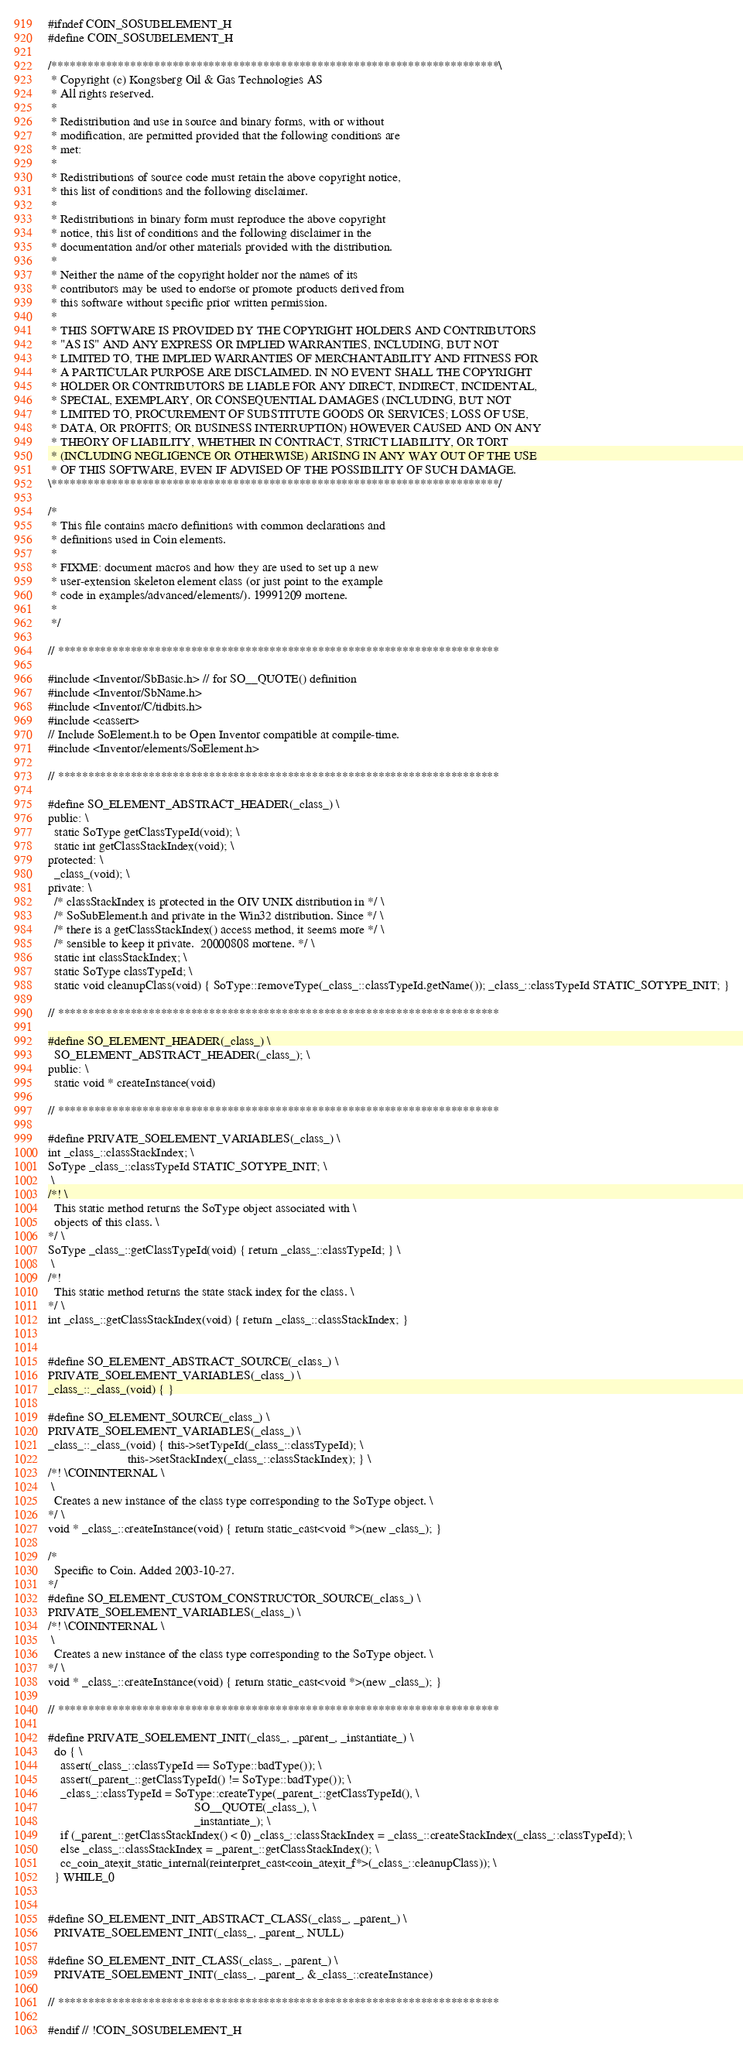Convert code to text. <code><loc_0><loc_0><loc_500><loc_500><_C_>#ifndef COIN_SOSUBELEMENT_H
#define COIN_SOSUBELEMENT_H

/**************************************************************************\
 * Copyright (c) Kongsberg Oil & Gas Technologies AS
 * All rights reserved.
 * 
 * Redistribution and use in source and binary forms, with or without
 * modification, are permitted provided that the following conditions are
 * met:
 * 
 * Redistributions of source code must retain the above copyright notice,
 * this list of conditions and the following disclaimer.
 * 
 * Redistributions in binary form must reproduce the above copyright
 * notice, this list of conditions and the following disclaimer in the
 * documentation and/or other materials provided with the distribution.
 * 
 * Neither the name of the copyright holder nor the names of its
 * contributors may be used to endorse or promote products derived from
 * this software without specific prior written permission.
 * 
 * THIS SOFTWARE IS PROVIDED BY THE COPYRIGHT HOLDERS AND CONTRIBUTORS
 * "AS IS" AND ANY EXPRESS OR IMPLIED WARRANTIES, INCLUDING, BUT NOT
 * LIMITED TO, THE IMPLIED WARRANTIES OF MERCHANTABILITY AND FITNESS FOR
 * A PARTICULAR PURPOSE ARE DISCLAIMED. IN NO EVENT SHALL THE COPYRIGHT
 * HOLDER OR CONTRIBUTORS BE LIABLE FOR ANY DIRECT, INDIRECT, INCIDENTAL,
 * SPECIAL, EXEMPLARY, OR CONSEQUENTIAL DAMAGES (INCLUDING, BUT NOT
 * LIMITED TO, PROCUREMENT OF SUBSTITUTE GOODS OR SERVICES; LOSS OF USE,
 * DATA, OR PROFITS; OR BUSINESS INTERRUPTION) HOWEVER CAUSED AND ON ANY
 * THEORY OF LIABILITY, WHETHER IN CONTRACT, STRICT LIABILITY, OR TORT
 * (INCLUDING NEGLIGENCE OR OTHERWISE) ARISING IN ANY WAY OUT OF THE USE
 * OF THIS SOFTWARE, EVEN IF ADVISED OF THE POSSIBILITY OF SUCH DAMAGE.
\**************************************************************************/

/*
 * This file contains macro definitions with common declarations and
 * definitions used in Coin elements.
 *
 * FIXME: document macros and how they are used to set up a new
 * user-extension skeleton element class (or just point to the example
 * code in examples/advanced/elements/). 19991209 mortene.
 *
 */

// *************************************************************************

#include <Inventor/SbBasic.h> // for SO__QUOTE() definition
#include <Inventor/SbName.h>
#include <Inventor/C/tidbits.h>
#include <cassert>
// Include SoElement.h to be Open Inventor compatible at compile-time.
#include <Inventor/elements/SoElement.h>

// *************************************************************************

#define SO_ELEMENT_ABSTRACT_HEADER(_class_) \
public: \
  static SoType getClassTypeId(void); \
  static int getClassStackIndex(void); \
protected: \
  _class_(void); \
private: \
  /* classStackIndex is protected in the OIV UNIX distribution in */ \
  /* SoSubElement.h and private in the Win32 distribution. Since */ \
  /* there is a getClassStackIndex() access method, it seems more */ \
  /* sensible to keep it private.  20000808 mortene. */ \
  static int classStackIndex; \
  static SoType classTypeId; \
  static void cleanupClass(void) { SoType::removeType(_class_::classTypeId.getName()); _class_::classTypeId STATIC_SOTYPE_INIT; }

// *************************************************************************

#define SO_ELEMENT_HEADER(_class_) \
  SO_ELEMENT_ABSTRACT_HEADER(_class_); \
public: \
  static void * createInstance(void)

// *************************************************************************

#define PRIVATE_SOELEMENT_VARIABLES(_class_) \
int _class_::classStackIndex; \
SoType _class_::classTypeId STATIC_SOTYPE_INIT; \
 \
/*! \
  This static method returns the SoType object associated with \
  objects of this class. \
*/ \
SoType _class_::getClassTypeId(void) { return _class_::classTypeId; } \
 \
/*!
  This static method returns the state stack index for the class. \
*/ \
int _class_::getClassStackIndex(void) { return _class_::classStackIndex; }


#define SO_ELEMENT_ABSTRACT_SOURCE(_class_) \
PRIVATE_SOELEMENT_VARIABLES(_class_) \
_class_::_class_(void) { }

#define SO_ELEMENT_SOURCE(_class_) \
PRIVATE_SOELEMENT_VARIABLES(_class_) \
_class_::_class_(void) { this->setTypeId(_class_::classTypeId); \
                         this->setStackIndex(_class_::classStackIndex); } \
/*! \COININTERNAL \
 \
  Creates a new instance of the class type corresponding to the SoType object. \
*/ \
void * _class_::createInstance(void) { return static_cast<void *>(new _class_); }

/*
  Specific to Coin. Added 2003-10-27.
*/
#define SO_ELEMENT_CUSTOM_CONSTRUCTOR_SOURCE(_class_) \
PRIVATE_SOELEMENT_VARIABLES(_class_) \
/*! \COININTERNAL \
 \
  Creates a new instance of the class type corresponding to the SoType object. \
*/ \
void * _class_::createInstance(void) { return static_cast<void *>(new _class_); }

// *************************************************************************

#define PRIVATE_SOELEMENT_INIT(_class_, _parent_, _instantiate_) \
  do { \
    assert(_class_::classTypeId == SoType::badType()); \
    assert(_parent_::getClassTypeId() != SoType::badType()); \
    _class_::classTypeId = SoType::createType(_parent_::getClassTypeId(), \
                                              SO__QUOTE(_class_), \
                                              _instantiate_); \
    if (_parent_::getClassStackIndex() < 0) _class_::classStackIndex = _class_::createStackIndex(_class_::classTypeId); \
    else _class_::classStackIndex = _parent_::getClassStackIndex(); \
    cc_coin_atexit_static_internal(reinterpret_cast<coin_atexit_f*>(_class_::cleanupClass)); \
  } WHILE_0


#define SO_ELEMENT_INIT_ABSTRACT_CLASS(_class_, _parent_) \
  PRIVATE_SOELEMENT_INIT(_class_, _parent_, NULL)

#define SO_ELEMENT_INIT_CLASS(_class_, _parent_) \
  PRIVATE_SOELEMENT_INIT(_class_, _parent_, &_class_::createInstance)

// *************************************************************************

#endif // !COIN_SOSUBELEMENT_H
</code> 